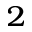<formula> <loc_0><loc_0><loc_500><loc_500>_ { 2 }</formula> 